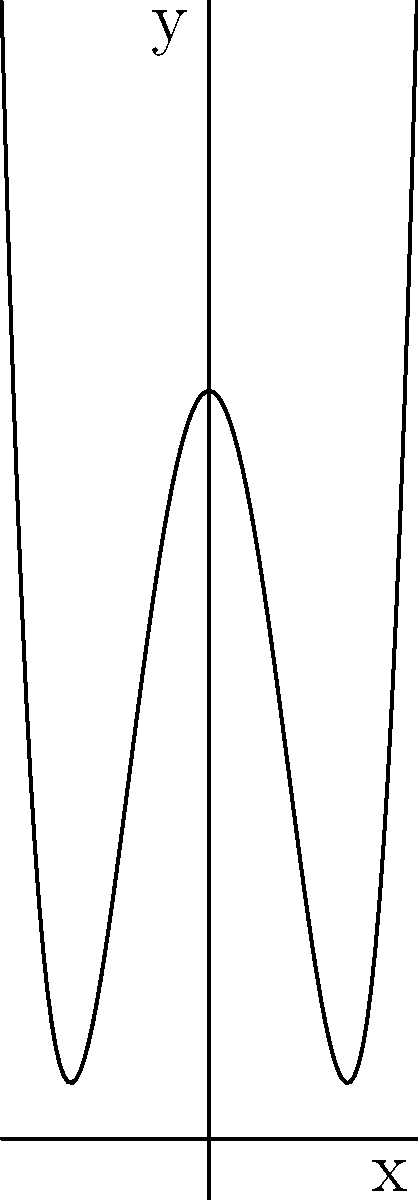As a fan of the Crickets and rock and roll, you're designing a custom guitar. The body shape can be represented by the polynomial function $f(x) = 0.005(x+10)(x-10)(x^2-100) + 4$. What is the y-intercept of this function, representing the midpoint of the guitar's body width? To find the y-intercept, we need to evaluate the function at x = 0:

1) Start with the function: $f(x) = 0.005(x+10)(x-10)(x^2-100) + 4$

2) Substitute x = 0:
   $f(0) = 0.005(0+10)(0-10)(0^2-100) + 4$

3) Simplify:
   $f(0) = 0.005(10)(-10)(-100) + 4$

4) Calculate:
   $f(0) = 0.005 * 10 * (-10) * (-100) + 4$
   $f(0) = 50 + 4$
   $f(0) = 54$

Therefore, the y-intercept is 54, representing the midpoint of the guitar's body width in this polynomial model.
Answer: 54 